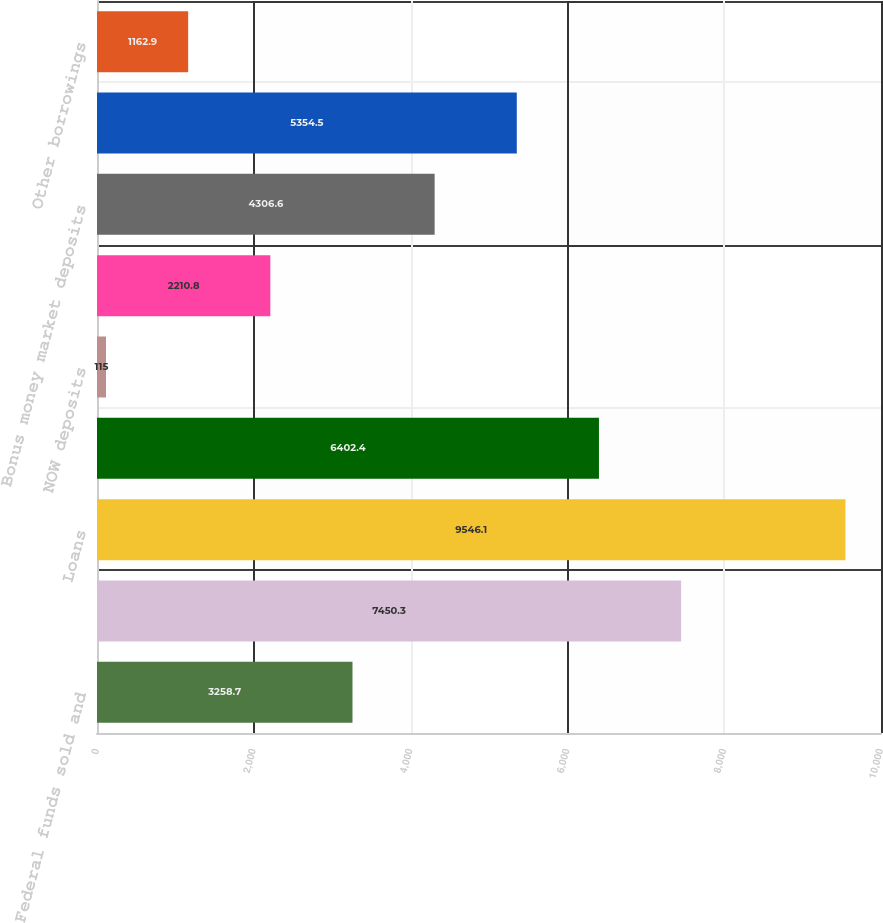Convert chart. <chart><loc_0><loc_0><loc_500><loc_500><bar_chart><fcel>Federal funds sold and<fcel>Investment securities<fcel>Loans<fcel>Increase (decrease) in<fcel>NOW deposits<fcel>Regular money market deposits<fcel>Bonus money market deposits<fcel>Time deposits<fcel>Other borrowings<nl><fcel>3258.7<fcel>7450.3<fcel>9546.1<fcel>6402.4<fcel>115<fcel>2210.8<fcel>4306.6<fcel>5354.5<fcel>1162.9<nl></chart> 